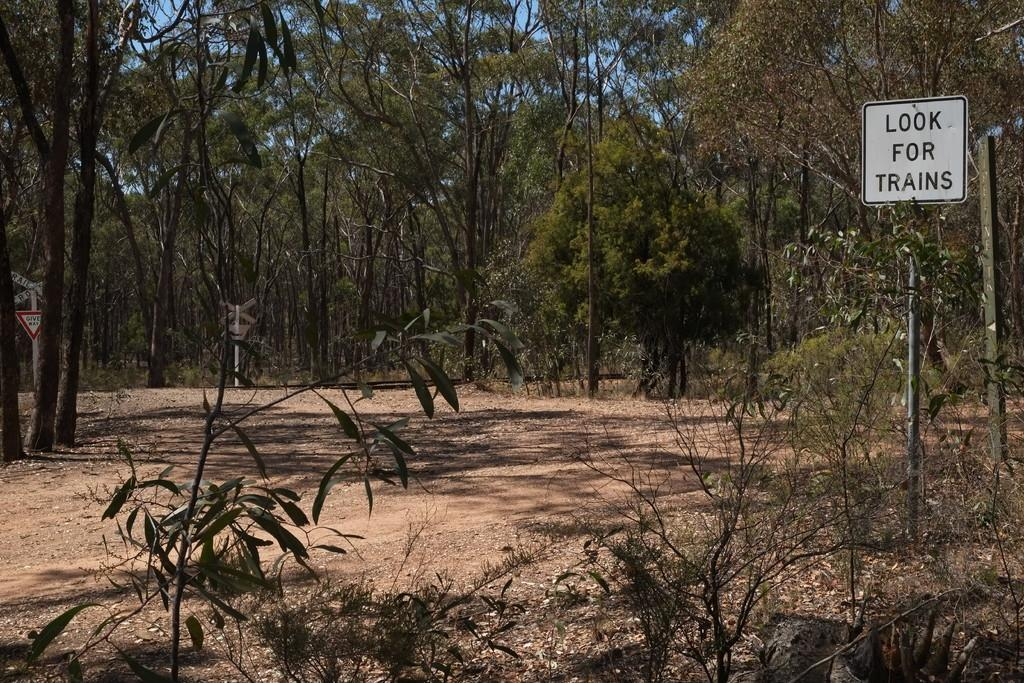What type of vegetation is present in the image? There are green plants and trees in the image. Where is the sign board located in the image? The sign board is on the right side of the image. What is the color of the sign board? The sign board is white. What type of ground surface is visible in the image? There is sand visible on the ground in the image. Can you see a notebook being used by a snake in the image? There is no notebook or snake present in the image. 